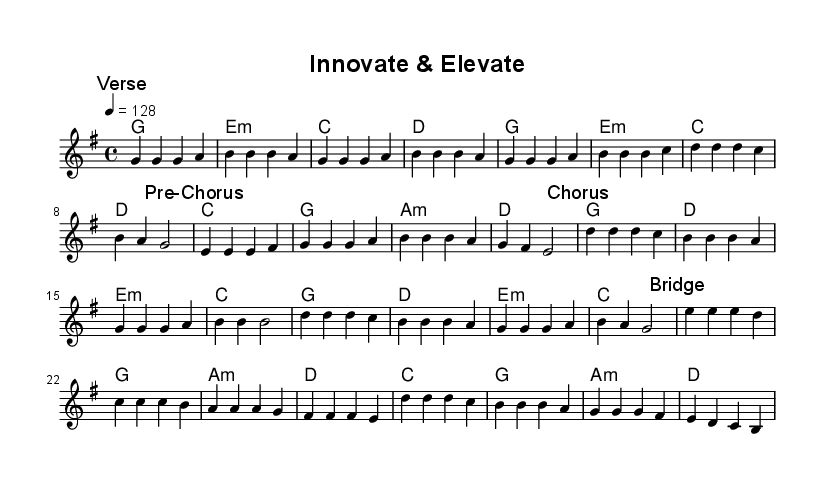What is the key signature of this music? The key signature is G major, which has one sharp (F#). Looking at the music notation at the beginning, we see the sharp sign placed on the F line of the staff.
Answer: G major What is the time signature of this music? The time signature is 4/4, shown at the beginning of the score. This means there are four beats in each measure, and the quarter note receives one beat.
Answer: 4/4 What is the tempo for this piece? The tempo is marked as 128 beats per minute, indicated by the number 4 = 128 at the beginning of the score. This means the quarter note will be played at a speed of 128 beats per minute.
Answer: 128 Identify the section that follows the "Pre-Chorus." The section that follows the "Pre-Chorus" is the "Chorus." Examining the markings in the score, the "Chorus" follows directly after the "Pre-Chorus" section.
Answer: Chorus How many measures are in the "Verse"? The "Verse" consists of 8 measures. By counting all the segments notated under the "Verse" mark, one can see there are a total of 8 measures.
Answer: 8 Which chord appears during the "Bridge" section? The chord appearing at the start of the "Bridge" section is E minor, as indicated by the chord notation written below the melody. Looking underneath the first line of the "Bridge" confirms this.
Answer: E minor What is the total number of unique sections in this piece? There are a total of 4 unique sections: Verse, Pre-Chorus, Chorus, and Bridge. Each section is clearly labeled in the score, allowing for easy identification.
Answer: 4 